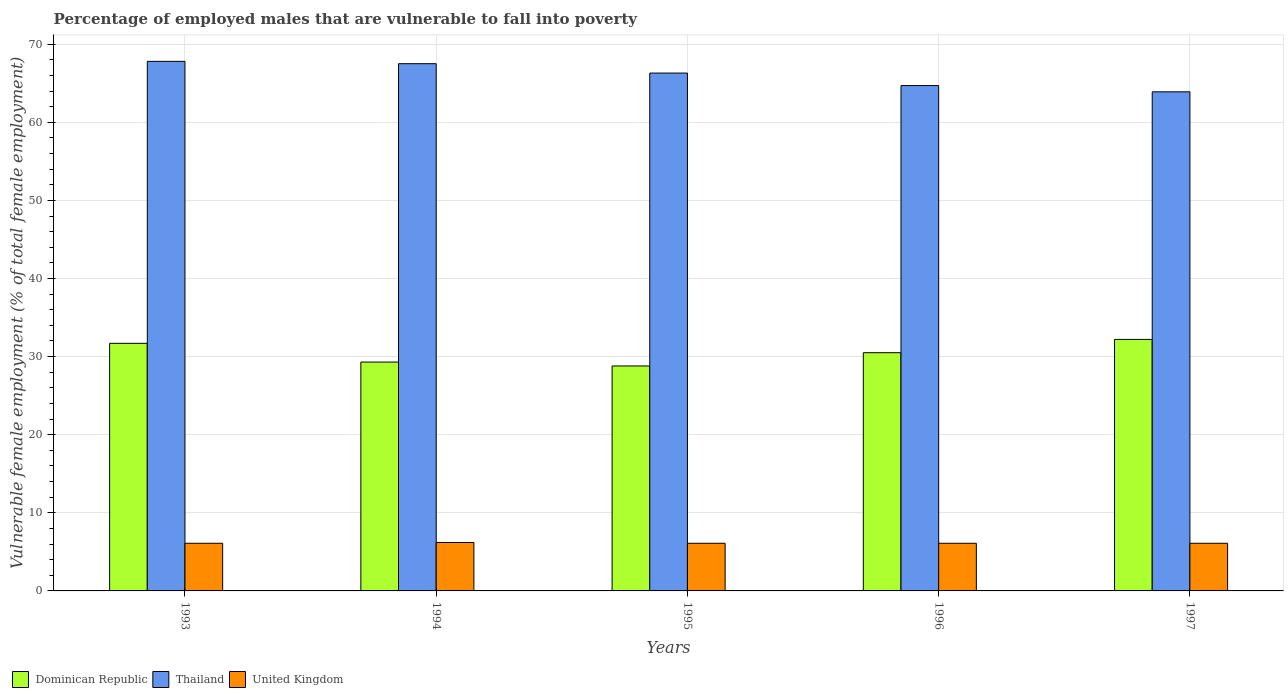How many different coloured bars are there?
Make the answer very short. 3. Are the number of bars on each tick of the X-axis equal?
Your response must be concise. Yes. How many bars are there on the 1st tick from the left?
Your response must be concise. 3. How many bars are there on the 1st tick from the right?
Offer a terse response. 3. In how many cases, is the number of bars for a given year not equal to the number of legend labels?
Provide a succinct answer. 0. What is the percentage of employed males who are vulnerable to fall into poverty in United Kingdom in 1997?
Your response must be concise. 6.1. Across all years, what is the maximum percentage of employed males who are vulnerable to fall into poverty in United Kingdom?
Give a very brief answer. 6.2. Across all years, what is the minimum percentage of employed males who are vulnerable to fall into poverty in United Kingdom?
Keep it short and to the point. 6.1. What is the total percentage of employed males who are vulnerable to fall into poverty in Thailand in the graph?
Offer a terse response. 330.2. What is the difference between the percentage of employed males who are vulnerable to fall into poverty in Dominican Republic in 1995 and that in 1997?
Keep it short and to the point. -3.4. What is the difference between the percentage of employed males who are vulnerable to fall into poverty in Thailand in 1994 and the percentage of employed males who are vulnerable to fall into poverty in Dominican Republic in 1995?
Offer a terse response. 38.7. What is the average percentage of employed males who are vulnerable to fall into poverty in United Kingdom per year?
Keep it short and to the point. 6.12. In the year 1995, what is the difference between the percentage of employed males who are vulnerable to fall into poverty in Thailand and percentage of employed males who are vulnerable to fall into poverty in United Kingdom?
Your response must be concise. 60.2. In how many years, is the percentage of employed males who are vulnerable to fall into poverty in Thailand greater than 66 %?
Give a very brief answer. 3. What is the ratio of the percentage of employed males who are vulnerable to fall into poverty in Dominican Republic in 1995 to that in 1997?
Make the answer very short. 0.89. Is the percentage of employed males who are vulnerable to fall into poverty in United Kingdom in 1995 less than that in 1997?
Your response must be concise. No. What is the difference between the highest and the second highest percentage of employed males who are vulnerable to fall into poverty in United Kingdom?
Ensure brevity in your answer.  0.1. What is the difference between the highest and the lowest percentage of employed males who are vulnerable to fall into poverty in Dominican Republic?
Your answer should be compact. 3.4. What does the 1st bar from the right in 1997 represents?
Provide a short and direct response. United Kingdom. How many years are there in the graph?
Ensure brevity in your answer.  5. What is the difference between two consecutive major ticks on the Y-axis?
Offer a very short reply. 10. Are the values on the major ticks of Y-axis written in scientific E-notation?
Keep it short and to the point. No. Where does the legend appear in the graph?
Your response must be concise. Bottom left. How are the legend labels stacked?
Offer a terse response. Horizontal. What is the title of the graph?
Your answer should be compact. Percentage of employed males that are vulnerable to fall into poverty. Does "Togo" appear as one of the legend labels in the graph?
Your answer should be very brief. No. What is the label or title of the X-axis?
Offer a very short reply. Years. What is the label or title of the Y-axis?
Make the answer very short. Vulnerable female employment (% of total female employment). What is the Vulnerable female employment (% of total female employment) of Dominican Republic in 1993?
Your response must be concise. 31.7. What is the Vulnerable female employment (% of total female employment) in Thailand in 1993?
Offer a terse response. 67.8. What is the Vulnerable female employment (% of total female employment) of United Kingdom in 1993?
Offer a very short reply. 6.1. What is the Vulnerable female employment (% of total female employment) of Dominican Republic in 1994?
Ensure brevity in your answer.  29.3. What is the Vulnerable female employment (% of total female employment) in Thailand in 1994?
Keep it short and to the point. 67.5. What is the Vulnerable female employment (% of total female employment) of United Kingdom in 1994?
Provide a short and direct response. 6.2. What is the Vulnerable female employment (% of total female employment) in Dominican Republic in 1995?
Keep it short and to the point. 28.8. What is the Vulnerable female employment (% of total female employment) of Thailand in 1995?
Offer a terse response. 66.3. What is the Vulnerable female employment (% of total female employment) in United Kingdom in 1995?
Keep it short and to the point. 6.1. What is the Vulnerable female employment (% of total female employment) in Dominican Republic in 1996?
Offer a very short reply. 30.5. What is the Vulnerable female employment (% of total female employment) in Thailand in 1996?
Make the answer very short. 64.7. What is the Vulnerable female employment (% of total female employment) in United Kingdom in 1996?
Offer a very short reply. 6.1. What is the Vulnerable female employment (% of total female employment) in Dominican Republic in 1997?
Offer a very short reply. 32.2. What is the Vulnerable female employment (% of total female employment) of Thailand in 1997?
Give a very brief answer. 63.9. What is the Vulnerable female employment (% of total female employment) of United Kingdom in 1997?
Provide a succinct answer. 6.1. Across all years, what is the maximum Vulnerable female employment (% of total female employment) of Dominican Republic?
Make the answer very short. 32.2. Across all years, what is the maximum Vulnerable female employment (% of total female employment) of Thailand?
Your response must be concise. 67.8. Across all years, what is the maximum Vulnerable female employment (% of total female employment) of United Kingdom?
Your answer should be very brief. 6.2. Across all years, what is the minimum Vulnerable female employment (% of total female employment) of Dominican Republic?
Give a very brief answer. 28.8. Across all years, what is the minimum Vulnerable female employment (% of total female employment) in Thailand?
Offer a very short reply. 63.9. Across all years, what is the minimum Vulnerable female employment (% of total female employment) of United Kingdom?
Your response must be concise. 6.1. What is the total Vulnerable female employment (% of total female employment) of Dominican Republic in the graph?
Your response must be concise. 152.5. What is the total Vulnerable female employment (% of total female employment) in Thailand in the graph?
Your response must be concise. 330.2. What is the total Vulnerable female employment (% of total female employment) in United Kingdom in the graph?
Keep it short and to the point. 30.6. What is the difference between the Vulnerable female employment (% of total female employment) in Dominican Republic in 1993 and that in 1994?
Offer a very short reply. 2.4. What is the difference between the Vulnerable female employment (% of total female employment) in Thailand in 1993 and that in 1996?
Provide a succinct answer. 3.1. What is the difference between the Vulnerable female employment (% of total female employment) in United Kingdom in 1993 and that in 1997?
Offer a terse response. 0. What is the difference between the Vulnerable female employment (% of total female employment) in Dominican Republic in 1994 and that in 1996?
Your answer should be compact. -1.2. What is the difference between the Vulnerable female employment (% of total female employment) of Thailand in 1994 and that in 1996?
Offer a very short reply. 2.8. What is the difference between the Vulnerable female employment (% of total female employment) in United Kingdom in 1994 and that in 1996?
Provide a short and direct response. 0.1. What is the difference between the Vulnerable female employment (% of total female employment) in Thailand in 1995 and that in 1996?
Your answer should be compact. 1.6. What is the difference between the Vulnerable female employment (% of total female employment) of United Kingdom in 1995 and that in 1996?
Your answer should be very brief. 0. What is the difference between the Vulnerable female employment (% of total female employment) of Thailand in 1995 and that in 1997?
Keep it short and to the point. 2.4. What is the difference between the Vulnerable female employment (% of total female employment) in United Kingdom in 1995 and that in 1997?
Give a very brief answer. 0. What is the difference between the Vulnerable female employment (% of total female employment) of Dominican Republic in 1993 and the Vulnerable female employment (% of total female employment) of Thailand in 1994?
Give a very brief answer. -35.8. What is the difference between the Vulnerable female employment (% of total female employment) of Thailand in 1993 and the Vulnerable female employment (% of total female employment) of United Kingdom in 1994?
Provide a short and direct response. 61.6. What is the difference between the Vulnerable female employment (% of total female employment) of Dominican Republic in 1993 and the Vulnerable female employment (% of total female employment) of Thailand in 1995?
Keep it short and to the point. -34.6. What is the difference between the Vulnerable female employment (% of total female employment) in Dominican Republic in 1993 and the Vulnerable female employment (% of total female employment) in United Kingdom in 1995?
Your response must be concise. 25.6. What is the difference between the Vulnerable female employment (% of total female employment) in Thailand in 1993 and the Vulnerable female employment (% of total female employment) in United Kingdom in 1995?
Offer a very short reply. 61.7. What is the difference between the Vulnerable female employment (% of total female employment) in Dominican Republic in 1993 and the Vulnerable female employment (% of total female employment) in Thailand in 1996?
Ensure brevity in your answer.  -33. What is the difference between the Vulnerable female employment (% of total female employment) of Dominican Republic in 1993 and the Vulnerable female employment (% of total female employment) of United Kingdom in 1996?
Make the answer very short. 25.6. What is the difference between the Vulnerable female employment (% of total female employment) of Thailand in 1993 and the Vulnerable female employment (% of total female employment) of United Kingdom in 1996?
Your answer should be very brief. 61.7. What is the difference between the Vulnerable female employment (% of total female employment) in Dominican Republic in 1993 and the Vulnerable female employment (% of total female employment) in Thailand in 1997?
Your answer should be very brief. -32.2. What is the difference between the Vulnerable female employment (% of total female employment) of Dominican Republic in 1993 and the Vulnerable female employment (% of total female employment) of United Kingdom in 1997?
Provide a short and direct response. 25.6. What is the difference between the Vulnerable female employment (% of total female employment) in Thailand in 1993 and the Vulnerable female employment (% of total female employment) in United Kingdom in 1997?
Provide a short and direct response. 61.7. What is the difference between the Vulnerable female employment (% of total female employment) in Dominican Republic in 1994 and the Vulnerable female employment (% of total female employment) in Thailand in 1995?
Your response must be concise. -37. What is the difference between the Vulnerable female employment (% of total female employment) of Dominican Republic in 1994 and the Vulnerable female employment (% of total female employment) of United Kingdom in 1995?
Offer a very short reply. 23.2. What is the difference between the Vulnerable female employment (% of total female employment) in Thailand in 1994 and the Vulnerable female employment (% of total female employment) in United Kingdom in 1995?
Offer a terse response. 61.4. What is the difference between the Vulnerable female employment (% of total female employment) of Dominican Republic in 1994 and the Vulnerable female employment (% of total female employment) of Thailand in 1996?
Ensure brevity in your answer.  -35.4. What is the difference between the Vulnerable female employment (% of total female employment) in Dominican Republic in 1994 and the Vulnerable female employment (% of total female employment) in United Kingdom in 1996?
Your response must be concise. 23.2. What is the difference between the Vulnerable female employment (% of total female employment) in Thailand in 1994 and the Vulnerable female employment (% of total female employment) in United Kingdom in 1996?
Provide a short and direct response. 61.4. What is the difference between the Vulnerable female employment (% of total female employment) of Dominican Republic in 1994 and the Vulnerable female employment (% of total female employment) of Thailand in 1997?
Make the answer very short. -34.6. What is the difference between the Vulnerable female employment (% of total female employment) of Dominican Republic in 1994 and the Vulnerable female employment (% of total female employment) of United Kingdom in 1997?
Provide a succinct answer. 23.2. What is the difference between the Vulnerable female employment (% of total female employment) in Thailand in 1994 and the Vulnerable female employment (% of total female employment) in United Kingdom in 1997?
Give a very brief answer. 61.4. What is the difference between the Vulnerable female employment (% of total female employment) in Dominican Republic in 1995 and the Vulnerable female employment (% of total female employment) in Thailand in 1996?
Make the answer very short. -35.9. What is the difference between the Vulnerable female employment (% of total female employment) of Dominican Republic in 1995 and the Vulnerable female employment (% of total female employment) of United Kingdom in 1996?
Offer a very short reply. 22.7. What is the difference between the Vulnerable female employment (% of total female employment) in Thailand in 1995 and the Vulnerable female employment (% of total female employment) in United Kingdom in 1996?
Provide a short and direct response. 60.2. What is the difference between the Vulnerable female employment (% of total female employment) in Dominican Republic in 1995 and the Vulnerable female employment (% of total female employment) in Thailand in 1997?
Keep it short and to the point. -35.1. What is the difference between the Vulnerable female employment (% of total female employment) of Dominican Republic in 1995 and the Vulnerable female employment (% of total female employment) of United Kingdom in 1997?
Your answer should be compact. 22.7. What is the difference between the Vulnerable female employment (% of total female employment) of Thailand in 1995 and the Vulnerable female employment (% of total female employment) of United Kingdom in 1997?
Give a very brief answer. 60.2. What is the difference between the Vulnerable female employment (% of total female employment) of Dominican Republic in 1996 and the Vulnerable female employment (% of total female employment) of Thailand in 1997?
Your response must be concise. -33.4. What is the difference between the Vulnerable female employment (% of total female employment) in Dominican Republic in 1996 and the Vulnerable female employment (% of total female employment) in United Kingdom in 1997?
Your answer should be very brief. 24.4. What is the difference between the Vulnerable female employment (% of total female employment) of Thailand in 1996 and the Vulnerable female employment (% of total female employment) of United Kingdom in 1997?
Make the answer very short. 58.6. What is the average Vulnerable female employment (% of total female employment) in Dominican Republic per year?
Provide a succinct answer. 30.5. What is the average Vulnerable female employment (% of total female employment) of Thailand per year?
Make the answer very short. 66.04. What is the average Vulnerable female employment (% of total female employment) in United Kingdom per year?
Provide a short and direct response. 6.12. In the year 1993, what is the difference between the Vulnerable female employment (% of total female employment) in Dominican Republic and Vulnerable female employment (% of total female employment) in Thailand?
Your answer should be very brief. -36.1. In the year 1993, what is the difference between the Vulnerable female employment (% of total female employment) in Dominican Republic and Vulnerable female employment (% of total female employment) in United Kingdom?
Make the answer very short. 25.6. In the year 1993, what is the difference between the Vulnerable female employment (% of total female employment) of Thailand and Vulnerable female employment (% of total female employment) of United Kingdom?
Ensure brevity in your answer.  61.7. In the year 1994, what is the difference between the Vulnerable female employment (% of total female employment) in Dominican Republic and Vulnerable female employment (% of total female employment) in Thailand?
Give a very brief answer. -38.2. In the year 1994, what is the difference between the Vulnerable female employment (% of total female employment) in Dominican Republic and Vulnerable female employment (% of total female employment) in United Kingdom?
Your answer should be compact. 23.1. In the year 1994, what is the difference between the Vulnerable female employment (% of total female employment) in Thailand and Vulnerable female employment (% of total female employment) in United Kingdom?
Your answer should be very brief. 61.3. In the year 1995, what is the difference between the Vulnerable female employment (% of total female employment) of Dominican Republic and Vulnerable female employment (% of total female employment) of Thailand?
Provide a succinct answer. -37.5. In the year 1995, what is the difference between the Vulnerable female employment (% of total female employment) of Dominican Republic and Vulnerable female employment (% of total female employment) of United Kingdom?
Your response must be concise. 22.7. In the year 1995, what is the difference between the Vulnerable female employment (% of total female employment) of Thailand and Vulnerable female employment (% of total female employment) of United Kingdom?
Your answer should be compact. 60.2. In the year 1996, what is the difference between the Vulnerable female employment (% of total female employment) in Dominican Republic and Vulnerable female employment (% of total female employment) in Thailand?
Give a very brief answer. -34.2. In the year 1996, what is the difference between the Vulnerable female employment (% of total female employment) of Dominican Republic and Vulnerable female employment (% of total female employment) of United Kingdom?
Provide a short and direct response. 24.4. In the year 1996, what is the difference between the Vulnerable female employment (% of total female employment) in Thailand and Vulnerable female employment (% of total female employment) in United Kingdom?
Give a very brief answer. 58.6. In the year 1997, what is the difference between the Vulnerable female employment (% of total female employment) of Dominican Republic and Vulnerable female employment (% of total female employment) of Thailand?
Keep it short and to the point. -31.7. In the year 1997, what is the difference between the Vulnerable female employment (% of total female employment) in Dominican Republic and Vulnerable female employment (% of total female employment) in United Kingdom?
Ensure brevity in your answer.  26.1. In the year 1997, what is the difference between the Vulnerable female employment (% of total female employment) in Thailand and Vulnerable female employment (% of total female employment) in United Kingdom?
Your answer should be very brief. 57.8. What is the ratio of the Vulnerable female employment (% of total female employment) in Dominican Republic in 1993 to that in 1994?
Offer a terse response. 1.08. What is the ratio of the Vulnerable female employment (% of total female employment) in Thailand in 1993 to that in 1994?
Offer a terse response. 1. What is the ratio of the Vulnerable female employment (% of total female employment) of United Kingdom in 1993 to that in 1994?
Provide a succinct answer. 0.98. What is the ratio of the Vulnerable female employment (% of total female employment) in Dominican Republic in 1993 to that in 1995?
Provide a succinct answer. 1.1. What is the ratio of the Vulnerable female employment (% of total female employment) in Thailand in 1993 to that in 1995?
Keep it short and to the point. 1.02. What is the ratio of the Vulnerable female employment (% of total female employment) in United Kingdom in 1993 to that in 1995?
Give a very brief answer. 1. What is the ratio of the Vulnerable female employment (% of total female employment) in Dominican Republic in 1993 to that in 1996?
Give a very brief answer. 1.04. What is the ratio of the Vulnerable female employment (% of total female employment) in Thailand in 1993 to that in 1996?
Ensure brevity in your answer.  1.05. What is the ratio of the Vulnerable female employment (% of total female employment) of United Kingdom in 1993 to that in 1996?
Make the answer very short. 1. What is the ratio of the Vulnerable female employment (% of total female employment) of Dominican Republic in 1993 to that in 1997?
Provide a short and direct response. 0.98. What is the ratio of the Vulnerable female employment (% of total female employment) in Thailand in 1993 to that in 1997?
Keep it short and to the point. 1.06. What is the ratio of the Vulnerable female employment (% of total female employment) in United Kingdom in 1993 to that in 1997?
Ensure brevity in your answer.  1. What is the ratio of the Vulnerable female employment (% of total female employment) in Dominican Republic in 1994 to that in 1995?
Offer a terse response. 1.02. What is the ratio of the Vulnerable female employment (% of total female employment) of Thailand in 1994 to that in 1995?
Your answer should be compact. 1.02. What is the ratio of the Vulnerable female employment (% of total female employment) of United Kingdom in 1994 to that in 1995?
Offer a very short reply. 1.02. What is the ratio of the Vulnerable female employment (% of total female employment) in Dominican Republic in 1994 to that in 1996?
Ensure brevity in your answer.  0.96. What is the ratio of the Vulnerable female employment (% of total female employment) in Thailand in 1994 to that in 1996?
Your response must be concise. 1.04. What is the ratio of the Vulnerable female employment (% of total female employment) of United Kingdom in 1994 to that in 1996?
Provide a succinct answer. 1.02. What is the ratio of the Vulnerable female employment (% of total female employment) in Dominican Republic in 1994 to that in 1997?
Make the answer very short. 0.91. What is the ratio of the Vulnerable female employment (% of total female employment) of Thailand in 1994 to that in 1997?
Your response must be concise. 1.06. What is the ratio of the Vulnerable female employment (% of total female employment) of United Kingdom in 1994 to that in 1997?
Make the answer very short. 1.02. What is the ratio of the Vulnerable female employment (% of total female employment) in Dominican Republic in 1995 to that in 1996?
Your response must be concise. 0.94. What is the ratio of the Vulnerable female employment (% of total female employment) of Thailand in 1995 to that in 1996?
Ensure brevity in your answer.  1.02. What is the ratio of the Vulnerable female employment (% of total female employment) in Dominican Republic in 1995 to that in 1997?
Your answer should be very brief. 0.89. What is the ratio of the Vulnerable female employment (% of total female employment) in Thailand in 1995 to that in 1997?
Your response must be concise. 1.04. What is the ratio of the Vulnerable female employment (% of total female employment) in United Kingdom in 1995 to that in 1997?
Offer a terse response. 1. What is the ratio of the Vulnerable female employment (% of total female employment) of Dominican Republic in 1996 to that in 1997?
Provide a short and direct response. 0.95. What is the ratio of the Vulnerable female employment (% of total female employment) of Thailand in 1996 to that in 1997?
Keep it short and to the point. 1.01. What is the ratio of the Vulnerable female employment (% of total female employment) of United Kingdom in 1996 to that in 1997?
Offer a very short reply. 1. What is the difference between the highest and the second highest Vulnerable female employment (% of total female employment) of Dominican Republic?
Your answer should be very brief. 0.5. 